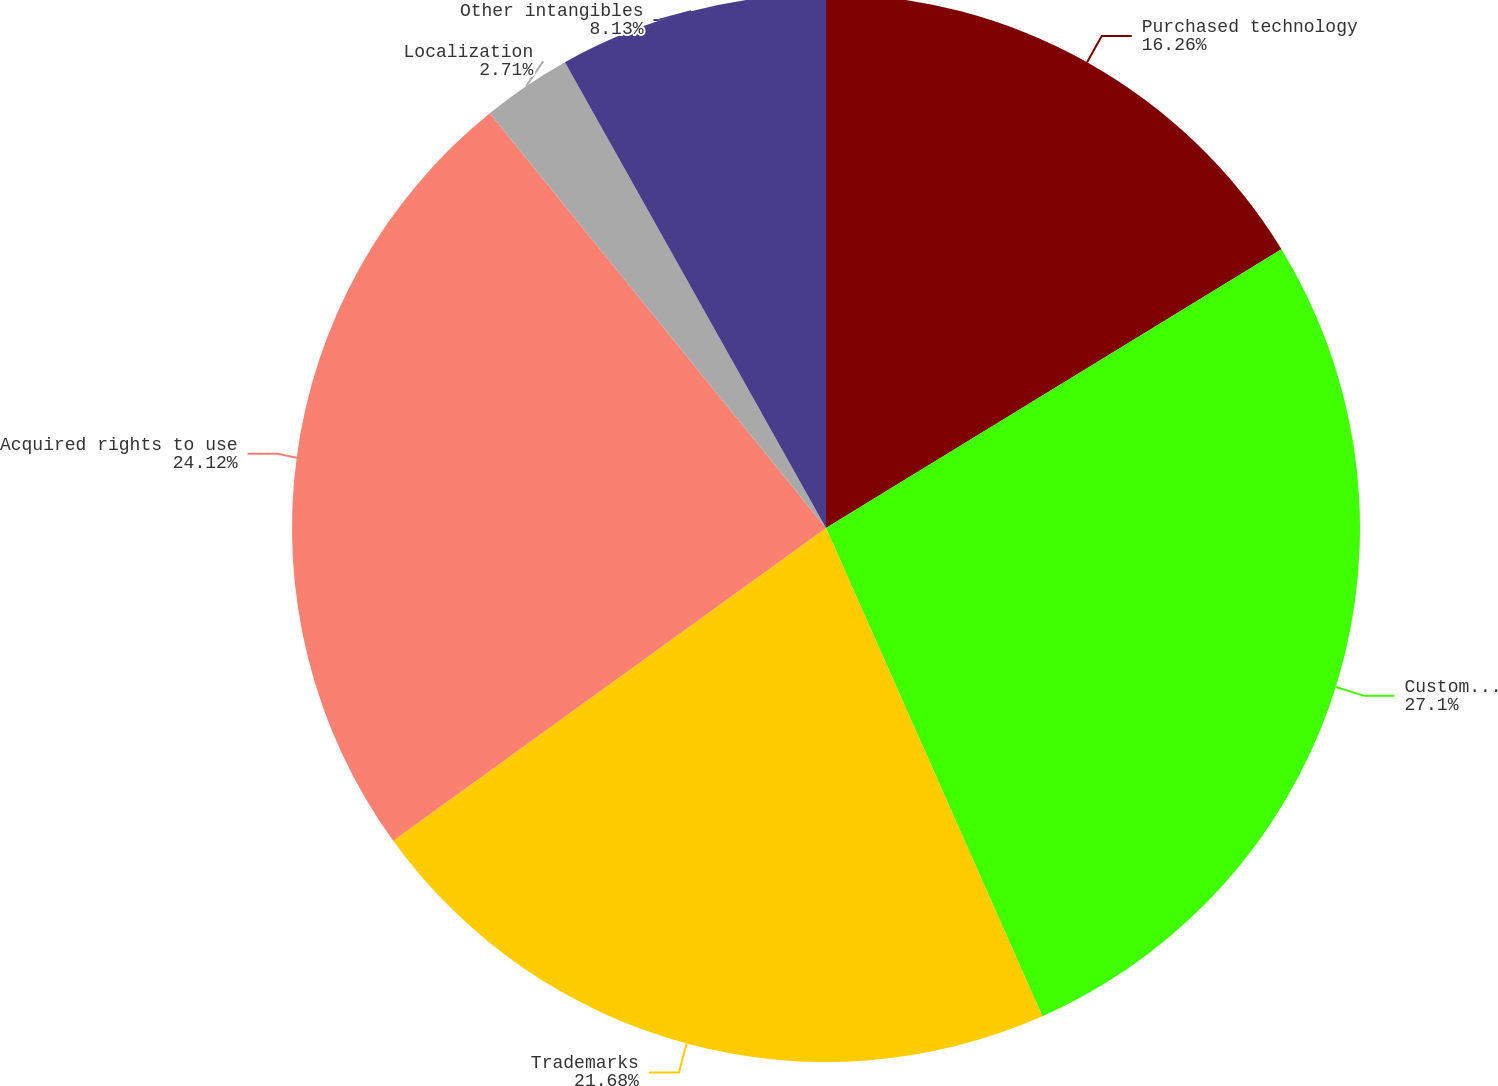<chart> <loc_0><loc_0><loc_500><loc_500><pie_chart><fcel>Purchased technology<fcel>Customer contracts and<fcel>Trademarks<fcel>Acquired rights to use<fcel>Localization<fcel>Other intangibles<nl><fcel>16.26%<fcel>27.1%<fcel>21.68%<fcel>24.12%<fcel>2.71%<fcel>8.13%<nl></chart> 